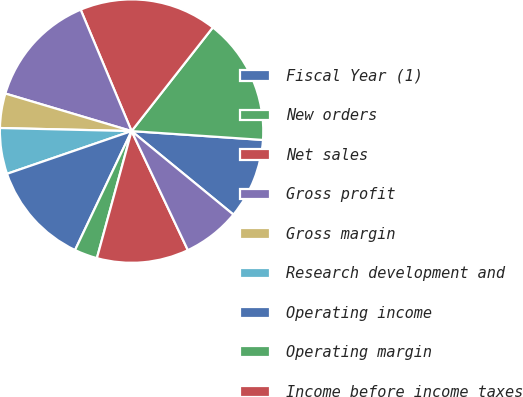<chart> <loc_0><loc_0><loc_500><loc_500><pie_chart><fcel>Fiscal Year (1)<fcel>New orders<fcel>Net sales<fcel>Gross profit<fcel>Gross margin<fcel>Research development and<fcel>Operating income<fcel>Operating margin<fcel>Income before income taxes<fcel>Net income<nl><fcel>9.86%<fcel>15.49%<fcel>16.9%<fcel>14.08%<fcel>4.23%<fcel>5.63%<fcel>12.68%<fcel>2.82%<fcel>11.27%<fcel>7.04%<nl></chart> 